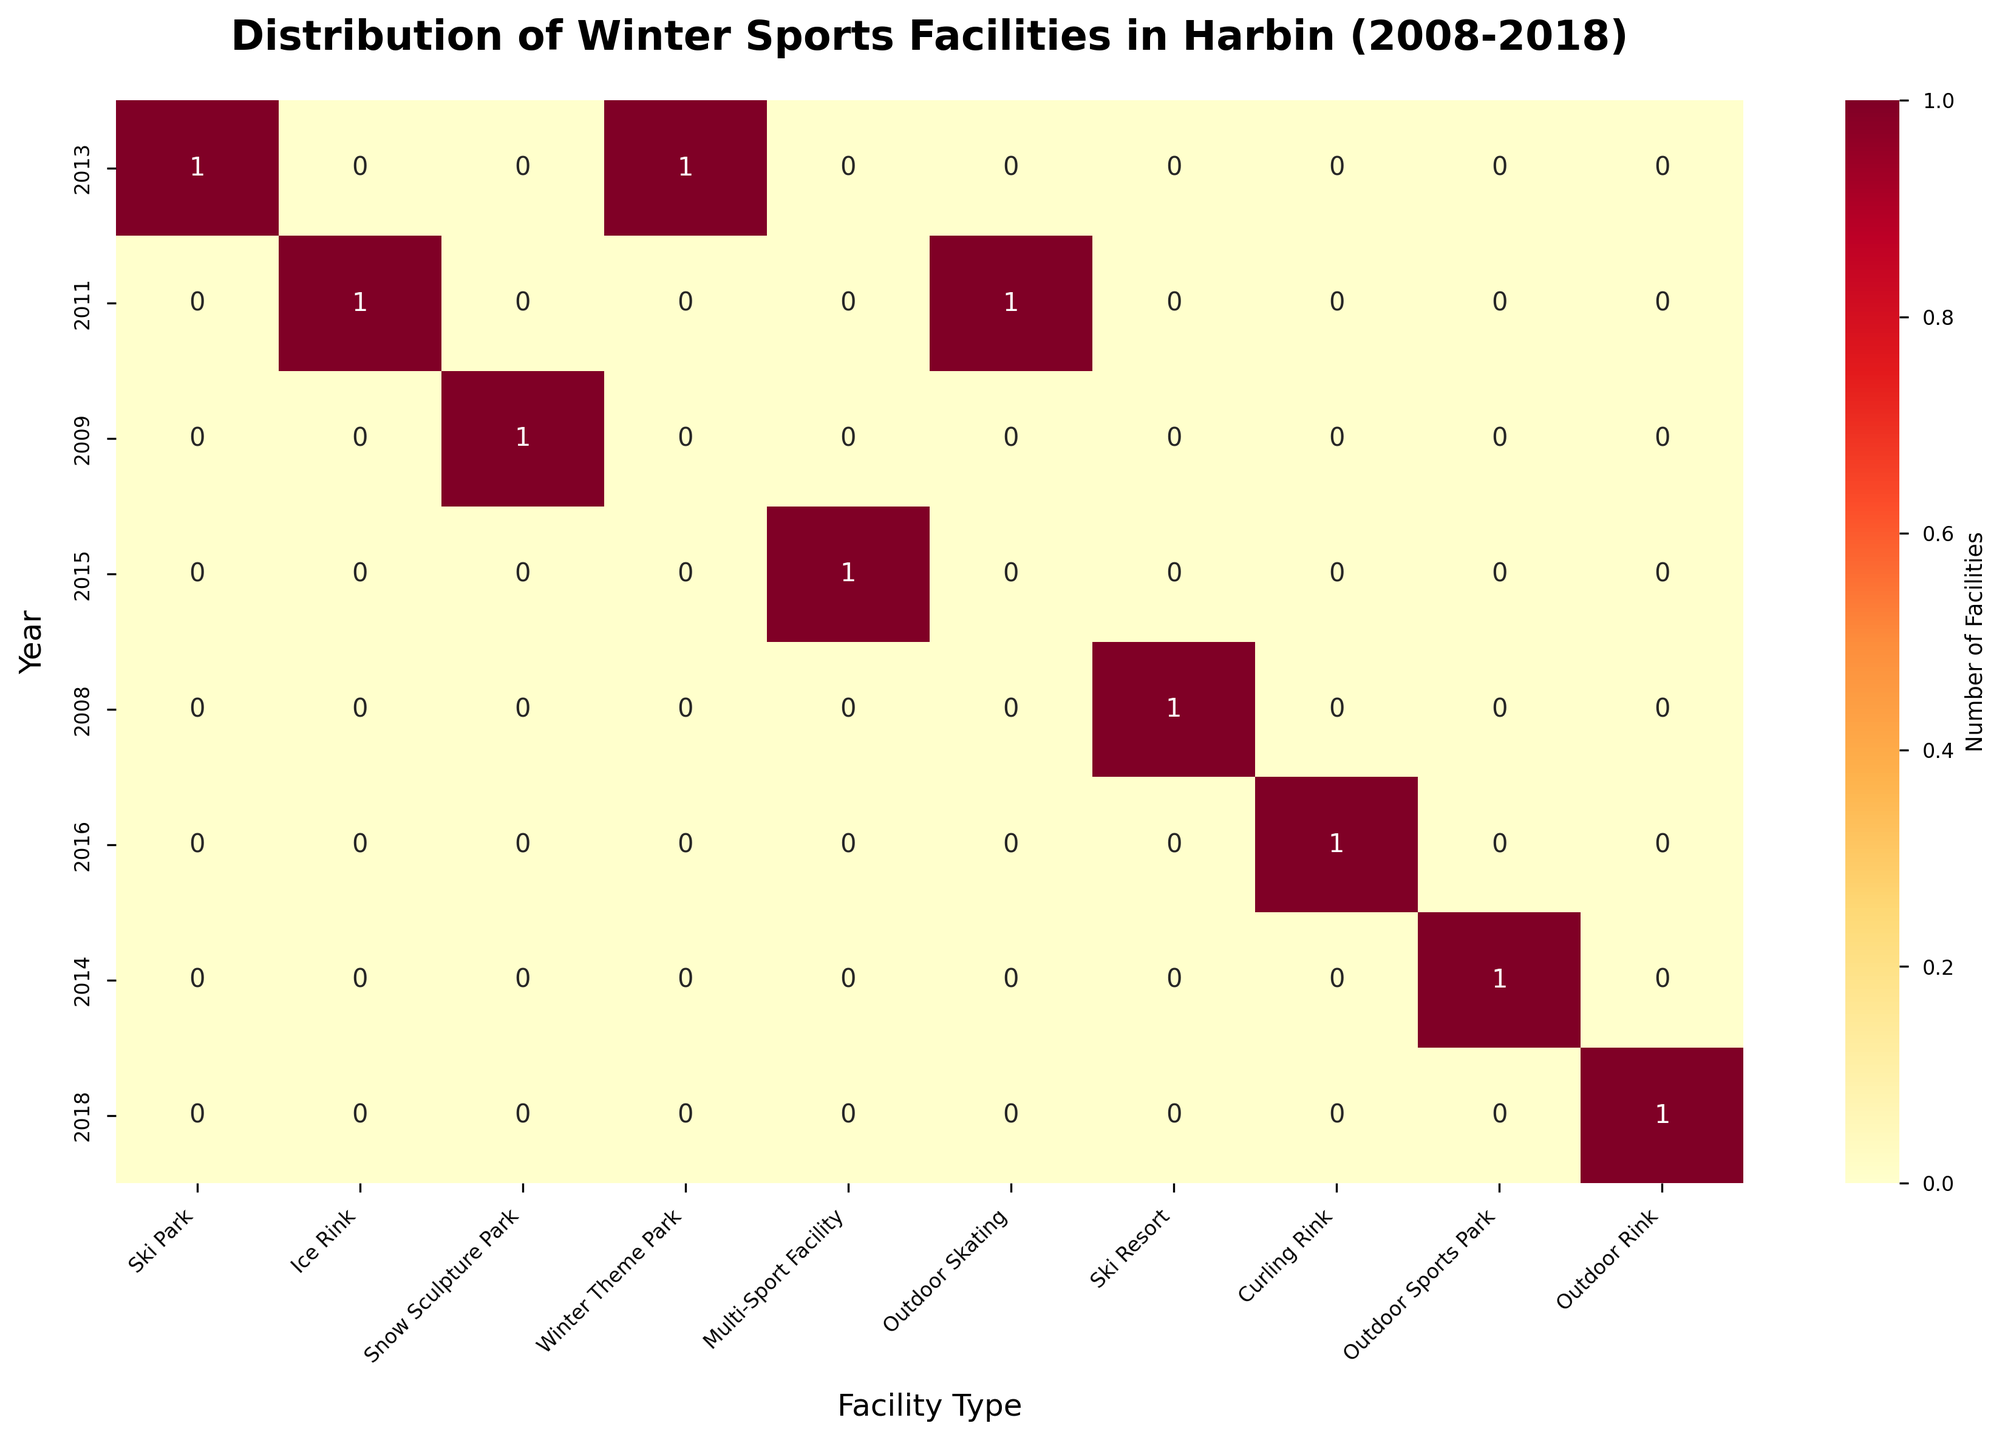What is the title of the heatmap? The title is typically displayed at the top center of the heatmap. The heatmap title reads "Distribution of Winter Sports Facilities in Harbin (2008-2018)."
Answer: Distribution of Winter Sports Facilities in Harbin (2008-2018) Which year has the highest number of facilities? To find the year with the highest number of facilities, look for the row with the most filled cells (with higher values). The year 2013 has the highest number of cells with non-zero values, indicating the highest number of winter sports facilities.
Answer: 2013 How many Ski Parks opened in 2013? Look at the row corresponding to the year 2013 and the column for Ski Parks. The cell value indicates the number of Ski Parks opened in that year, which is 1.
Answer: 1 Which type of facility had the most openings in 2011? In the row for 2011, find the column with the highest value. The facility type with the highest number in this row is Ice Rink, with 1 opening.
Answer: Ice Rink How does the number of facilities opened in 2015 compare to 2017? Compare the individual row totals for 2015 and 2017. The year 2015 shows some activity with at least one cell with a positive count, while 2017 does not have any entries. Thus, 2015 had more facilities opened than 2017.
Answer: 2015 had more Which facility type shows openings continuously from 2011 to 2016? Review each column and check for non-zero values for consecutive years from 2011 to 2016. The "Ice Rink" type has non-zero entries in the years 2011 and 2018, but “Multi-Sport Facility” appears from 2011 through 2016.
Answer: Multi-Sport Facility How many different types of facilities opened between 2011 and 2016? Review each column for any non-zero values within the 2011 to 2016 rows. The facility types with any openings during these years are Ski Park, Ice Rink, Multi-Sport Facility, Outdoor Skating, and Curling Rink, which totals to 5.
Answer: 5 What is the trend for Ice Rinks from 2008 to 2018? Look at the column for Ice Rinks and note the number of entries in each year from 2008 to 2018. Ice Rinks had openings in 2011 and 2018, with no facilities opened in other years, indicating intermittent growth.
Answer: Intermittent growth Which facility type had its first opening most recently, and in which year? Find the cell with the highest year value (most recent) for its first non-zero entry in the column. The "Siberian Tiger Park Skating Rink" (Outdoor Rink) had its first facility opened in 2018, being the most recent.
Answer: Outdoor Rink, 2018 